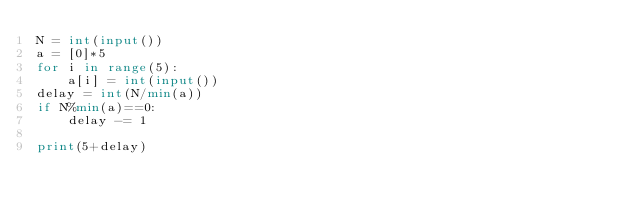Convert code to text. <code><loc_0><loc_0><loc_500><loc_500><_Python_>N = int(input())
a = [0]*5
for i in range(5):
    a[i] = int(input())
delay = int(N/min(a))
if N%min(a)==0:
    delay -= 1

print(5+delay)</code> 